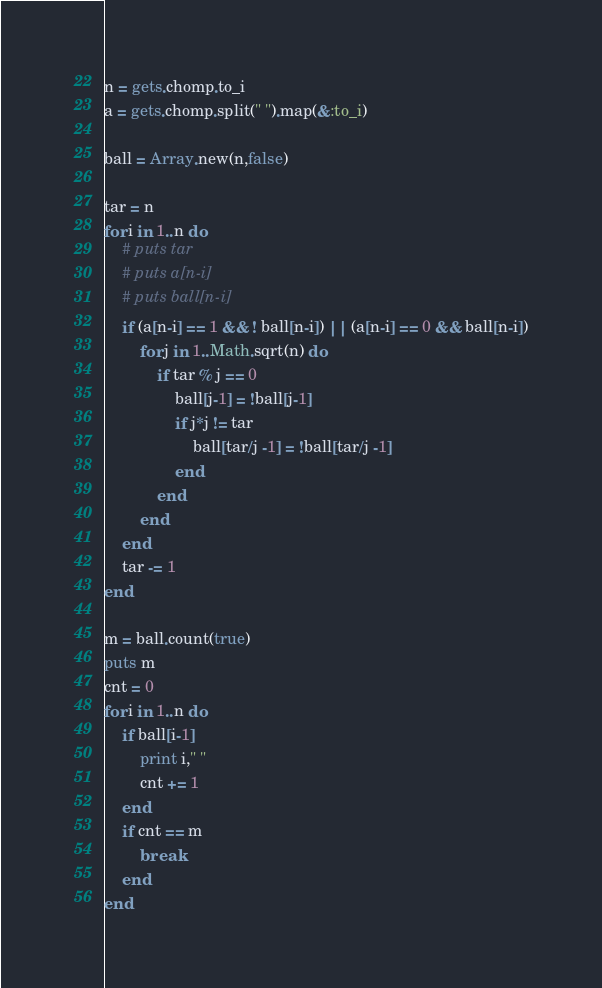Convert code to text. <code><loc_0><loc_0><loc_500><loc_500><_Ruby_>n = gets.chomp.to_i
a = gets.chomp.split(" ").map(&:to_i)

ball = Array.new(n,false)

tar = n
for i in 1..n do
    # puts tar
    # puts a[n-i]
    # puts ball[n-i]
    if (a[n-i] == 1 && ! ball[n-i]) || (a[n-i] == 0 && ball[n-i])
        for j in 1..Math.sqrt(n) do
            if tar % j == 0
                ball[j-1] = !ball[j-1]
                if j*j != tar
                    ball[tar/j -1] = !ball[tar/j -1]
                end
            end
        end
    end
    tar -= 1
end

m = ball.count(true)
puts m
cnt = 0
for i in 1..n do
    if ball[i-1]
        print i," "
        cnt += 1
    end
    if cnt == m
        break
    end
end
</code> 